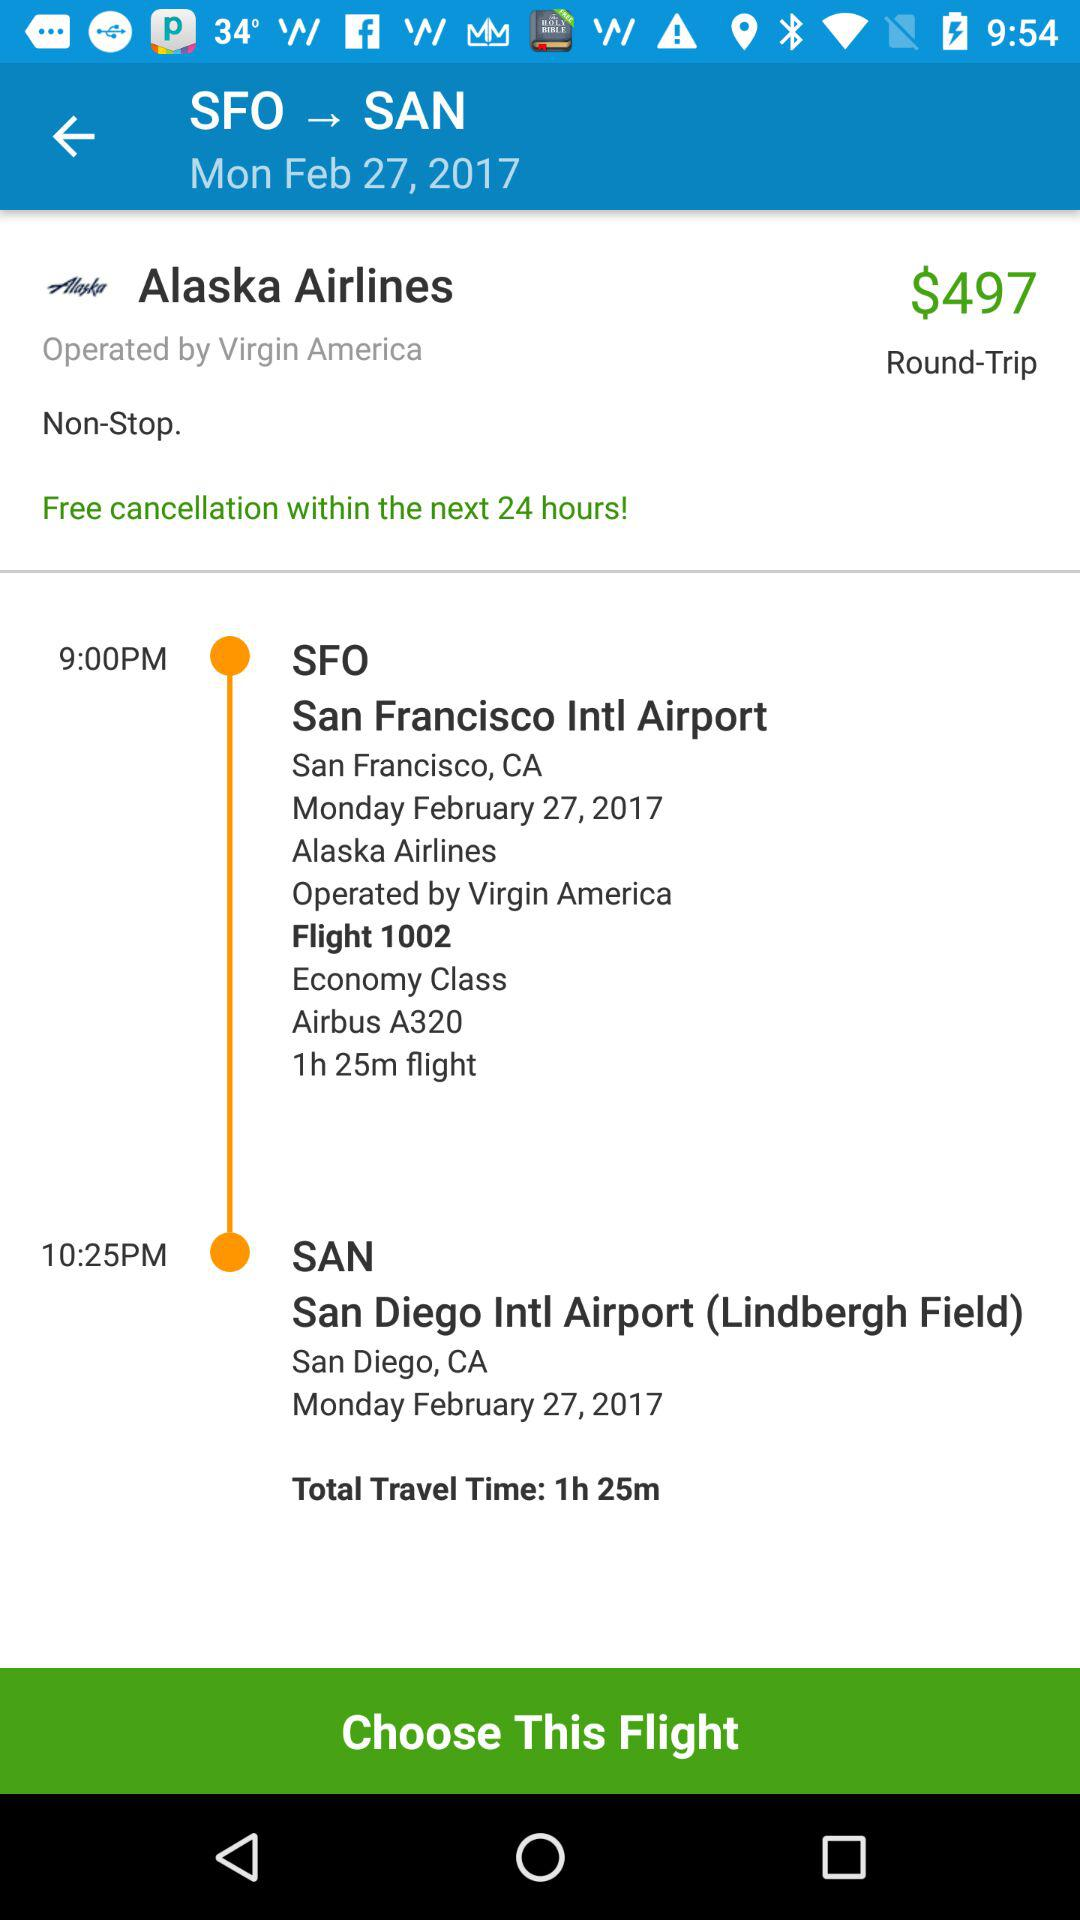What is the departure time of the flight? The departure time is 9 PM. 